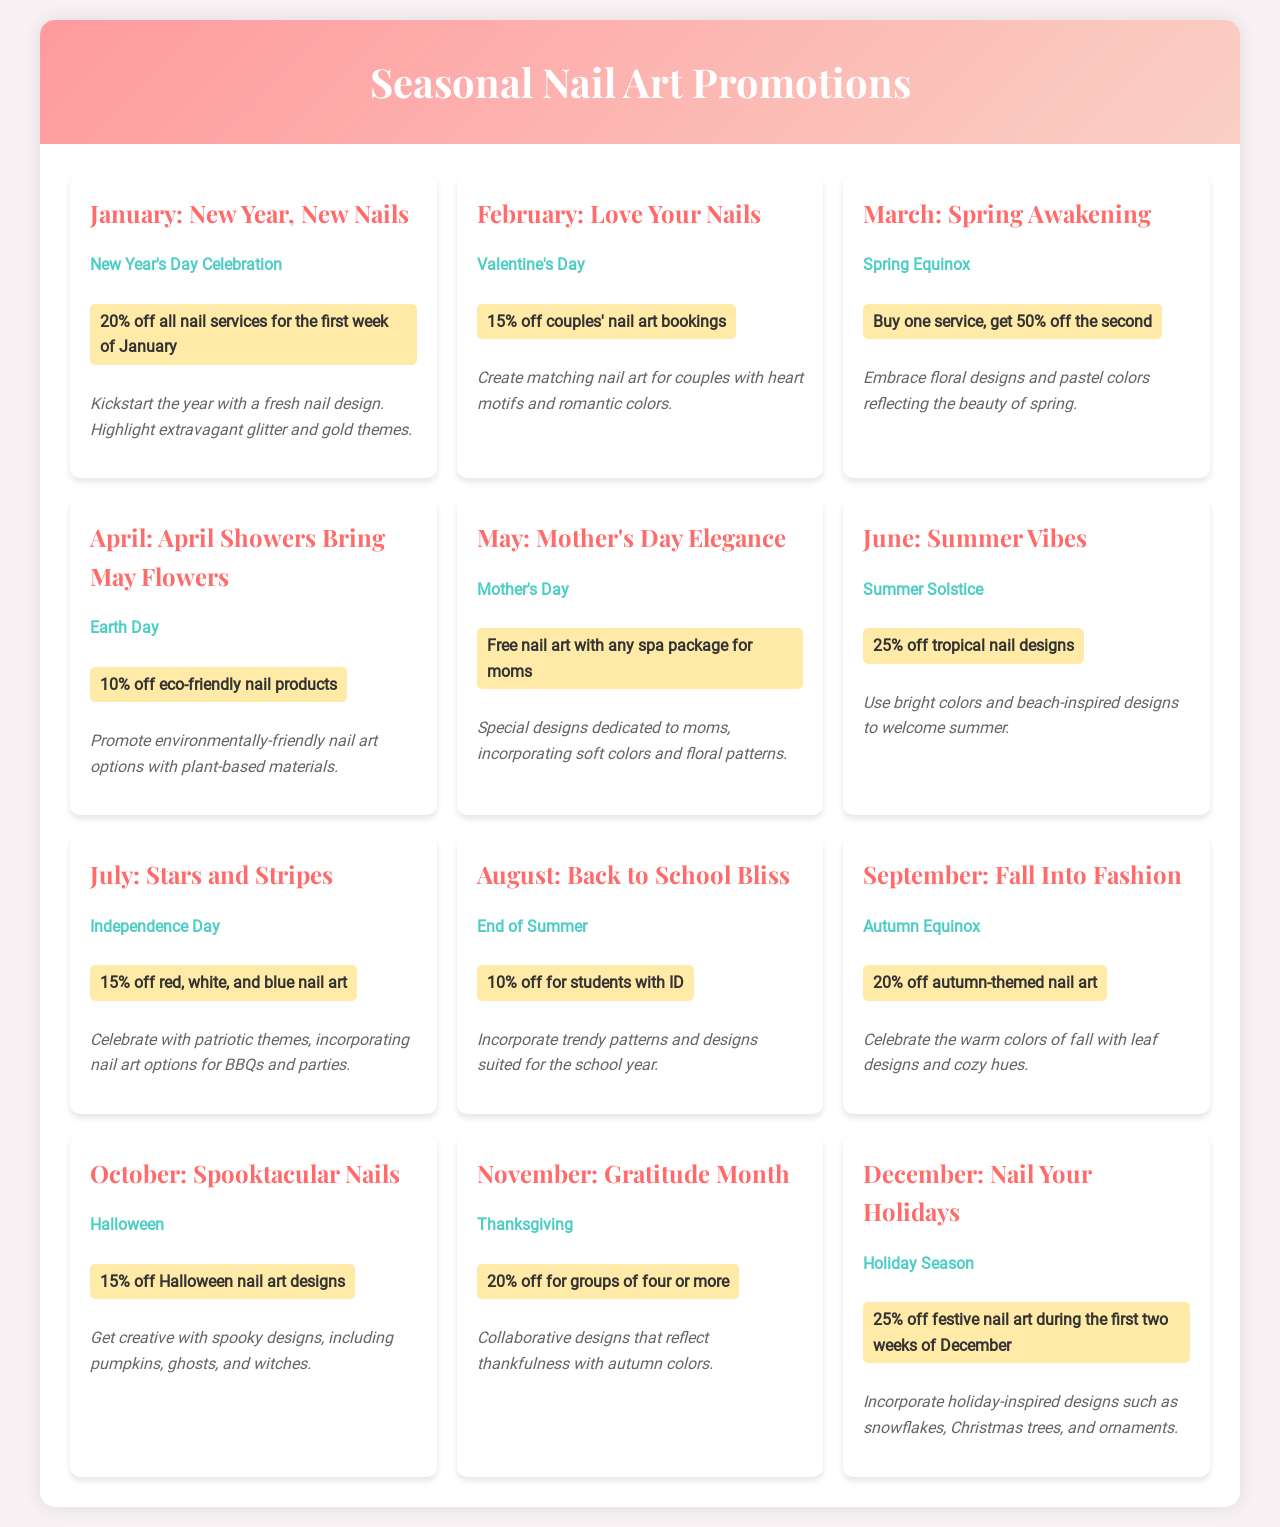What is the discount for New Year's Day? The discount for New Year's Day is stated at 20% off all nail services for the first week of January.
Answer: 20% off Which month has a promotion for Valentine's Day? The month that has a promotion for Valentine's Day is February.
Answer: February What is the special event celebrated in June? The special event celebrated in June is the Summer Solstice.
Answer: Summer Solstice What is the discount offered on Earth Day in April? The discount offered on Earth Day in April is 10% off eco-friendly nail products.
Answer: 10% off What type of designs are promoted in September? The type of designs promoted in September are autumn-themed nail art.
Answer: autumn-themed nail art How much is the discount for couples’ nail art bookings in February? The discount for couples' nail art bookings in February is 15%.
Answer: 15% What is offered for moms on Mother's Day in May? What is offered for moms on Mother's Day in May is free nail art with any spa package.
Answer: free nail art with any spa package What theme is highlighted for October's promotion? The theme highlighted for October's promotion revolves around Halloween.
Answer: Halloween How long does the December discount last for festive nail art? The December discount lasts for the first two weeks.
Answer: first two weeks 